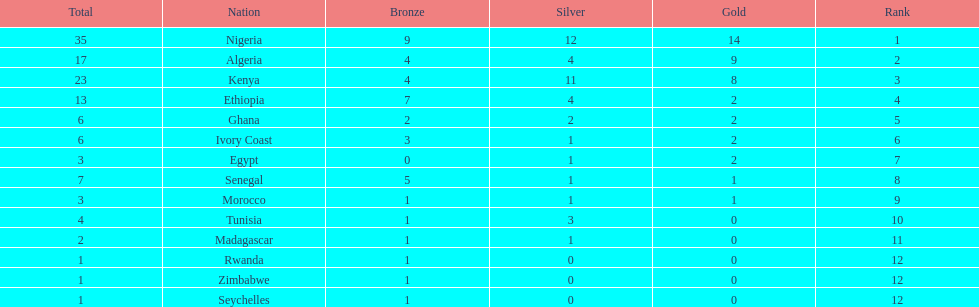Which country secured the lowest count of bronze medals? Egypt. 